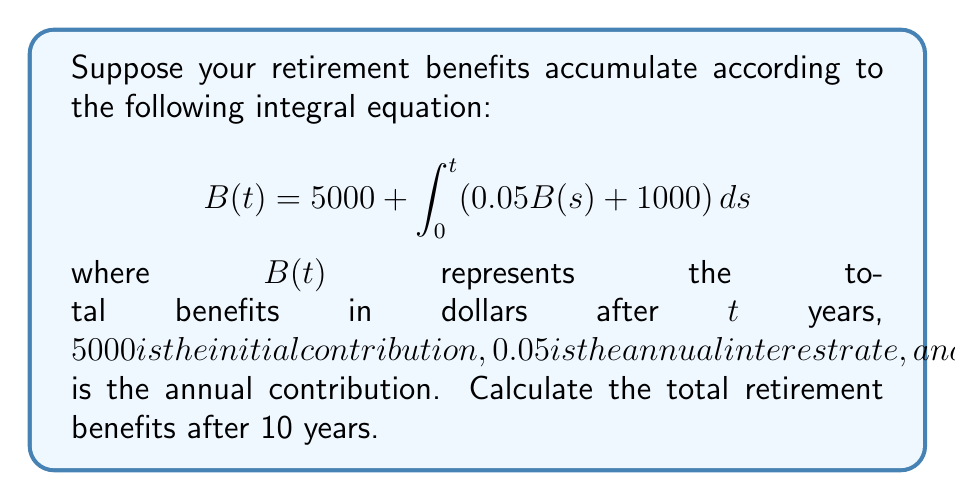Show me your answer to this math problem. To solve this integral equation, we'll use the following steps:

1) First, we differentiate both sides of the equation with respect to $t$:

   $$\frac{dB}{dt} = 0.05B(t) + 1000$$

2) This is now a first-order linear differential equation. We can solve it using the integrating factor method.

3) The integrating factor is $e^{\int 0.05 dt} = e^{0.05t}$

4) Multiplying both sides by the integrating factor:

   $$e^{0.05t}\frac{dB}{dt} = 0.05e^{0.05t}B(t) + 1000e^{0.05t}$$

5) The left side is now the derivative of $e^{0.05t}B(t)$. So we can write:

   $$\frac{d}{dt}(e^{0.05t}B(t)) = 1000e^{0.05t}$$

6) Integrating both sides:

   $$e^{0.05t}B(t) = 20000e^{0.05t} + C$$

7) Solving for $B(t)$:

   $$B(t) = 20000 + Ce^{-0.05t}$$

8) Using the initial condition $B(0) = 5000$, we can find $C$:

   $$5000 = 20000 + C$$
   $$C = -15000$$

9) Therefore, the solution is:

   $$B(t) = 20000 - 15000e^{-0.05t}$$

10) To find $B(10)$, we substitute $t = 10$:

    $$B(10) = 20000 - 15000e^{-0.5} \approx 11013.22$$
Answer: $11013.22 